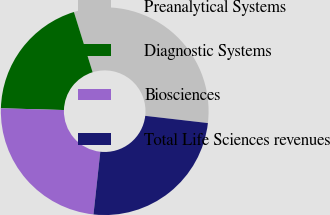<chart> <loc_0><loc_0><loc_500><loc_500><pie_chart><fcel>Preanalytical Systems<fcel>Diagnostic Systems<fcel>Biosciences<fcel>Total Life Sciences revenues<nl><fcel>31.62%<fcel>19.76%<fcel>23.72%<fcel>24.9%<nl></chart> 